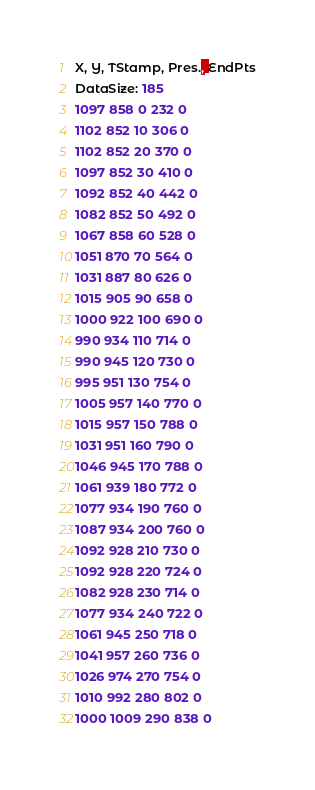Convert code to text. <code><loc_0><loc_0><loc_500><loc_500><_SML_>X, Y, TStamp, Pres., EndPts
DataSize: 185
1097 858 0 232 0
1102 852 10 306 0
1102 852 20 370 0
1097 852 30 410 0
1092 852 40 442 0
1082 852 50 492 0
1067 858 60 528 0
1051 870 70 564 0
1031 887 80 626 0
1015 905 90 658 0
1000 922 100 690 0
990 934 110 714 0
990 945 120 730 0
995 951 130 754 0
1005 957 140 770 0
1015 957 150 788 0
1031 951 160 790 0
1046 945 170 788 0
1061 939 180 772 0
1077 934 190 760 0
1087 934 200 760 0
1092 928 210 730 0
1092 928 220 724 0
1082 928 230 714 0
1077 934 240 722 0
1061 945 250 718 0
1041 957 260 736 0
1026 974 270 754 0
1010 992 280 802 0
1000 1009 290 838 0</code> 